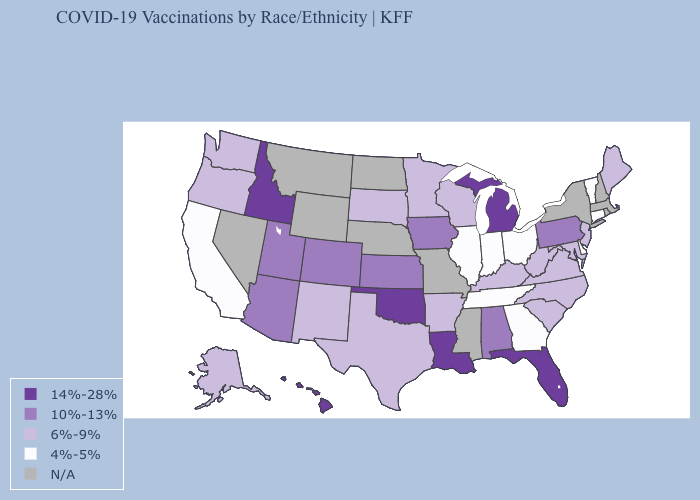What is the value of Kentucky?
Give a very brief answer. 6%-9%. Which states have the lowest value in the MidWest?
Give a very brief answer. Illinois, Indiana, Ohio. What is the value of Maine?
Quick response, please. 6%-9%. Does South Dakota have the lowest value in the USA?
Give a very brief answer. No. What is the value of Wisconsin?
Keep it brief. 6%-9%. What is the value of Wisconsin?
Keep it brief. 6%-9%. What is the value of Rhode Island?
Keep it brief. N/A. What is the value of Idaho?
Give a very brief answer. 14%-28%. Among the states that border New York , does Vermont have the highest value?
Quick response, please. No. Name the states that have a value in the range 4%-5%?
Quick response, please. California, Connecticut, Delaware, Georgia, Illinois, Indiana, Ohio, Tennessee, Vermont. Name the states that have a value in the range 4%-5%?
Answer briefly. California, Connecticut, Delaware, Georgia, Illinois, Indiana, Ohio, Tennessee, Vermont. What is the value of New Hampshire?
Concise answer only. N/A. Does California have the highest value in the USA?
Give a very brief answer. No. What is the lowest value in the USA?
Write a very short answer. 4%-5%. 